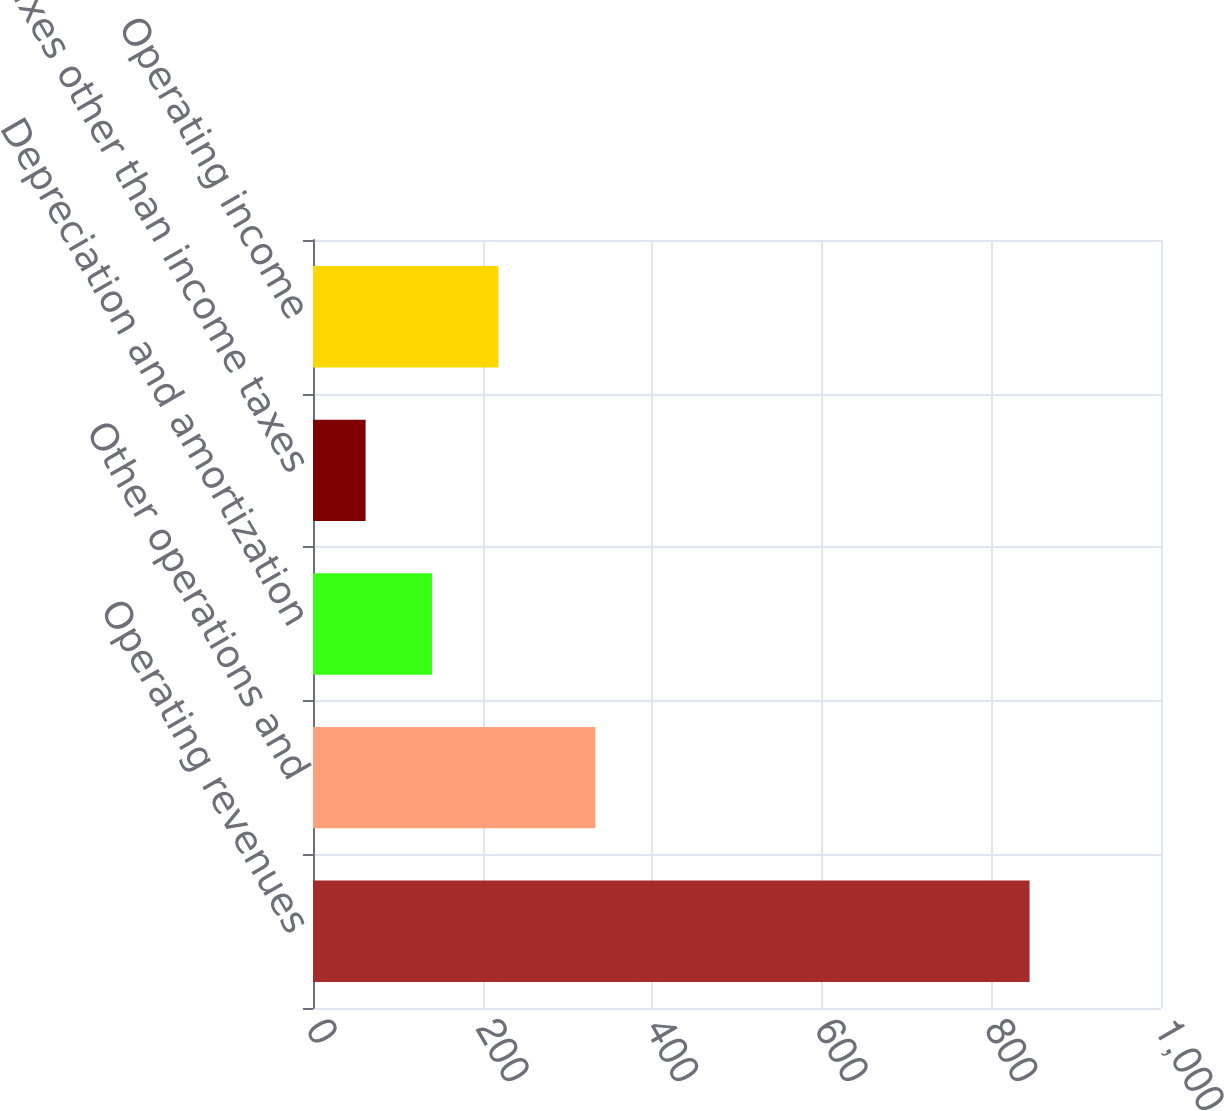Convert chart. <chart><loc_0><loc_0><loc_500><loc_500><bar_chart><fcel>Operating revenues<fcel>Other operations and<fcel>Depreciation and amortization<fcel>Taxes other than income taxes<fcel>Operating income<nl><fcel>845<fcel>333<fcel>140.3<fcel>62<fcel>218.6<nl></chart> 